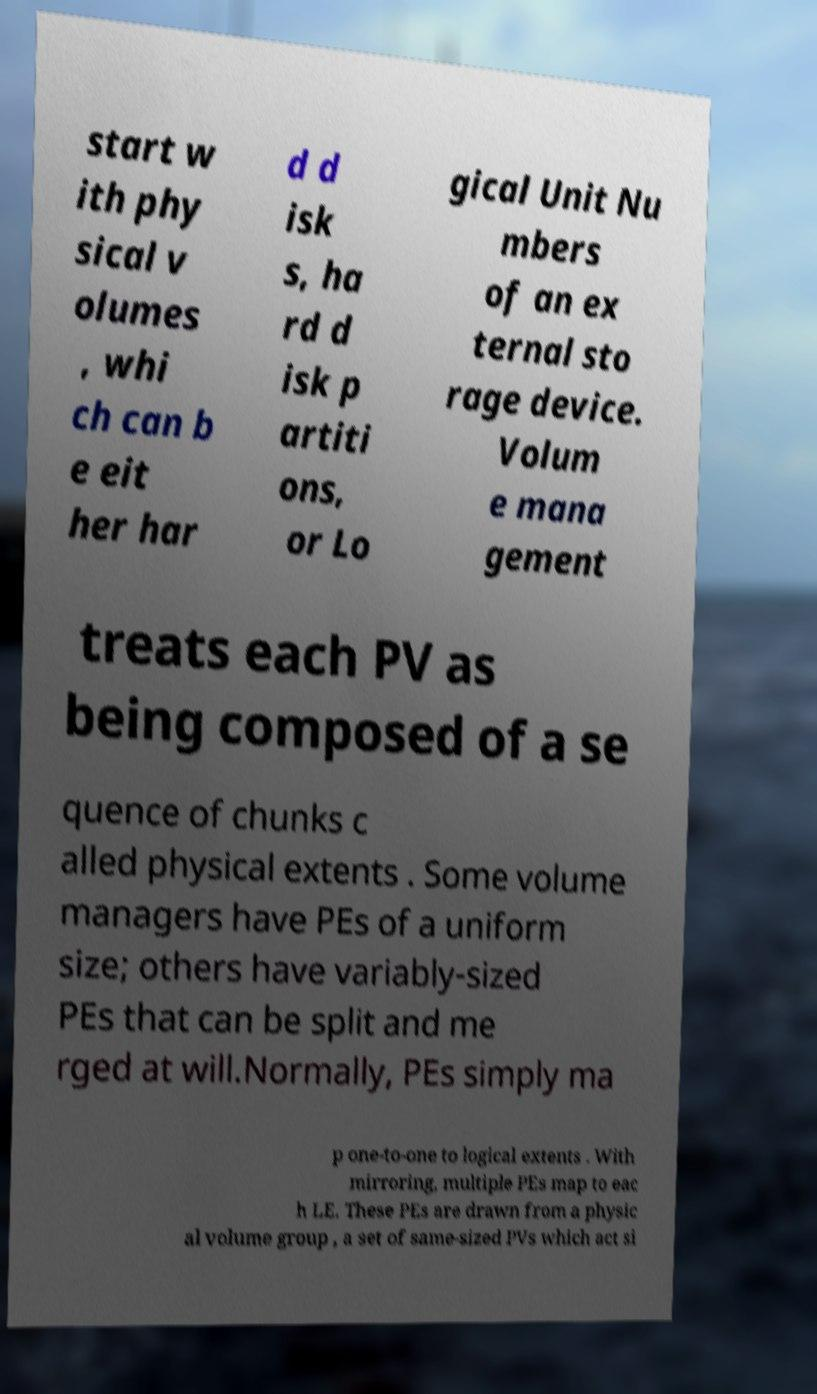Please read and relay the text visible in this image. What does it say? start w ith phy sical v olumes , whi ch can b e eit her har d d isk s, ha rd d isk p artiti ons, or Lo gical Unit Nu mbers of an ex ternal sto rage device. Volum e mana gement treats each PV as being composed of a se quence of chunks c alled physical extents . Some volume managers have PEs of a uniform size; others have variably-sized PEs that can be split and me rged at will.Normally, PEs simply ma p one-to-one to logical extents . With mirroring, multiple PEs map to eac h LE. These PEs are drawn from a physic al volume group , a set of same-sized PVs which act si 